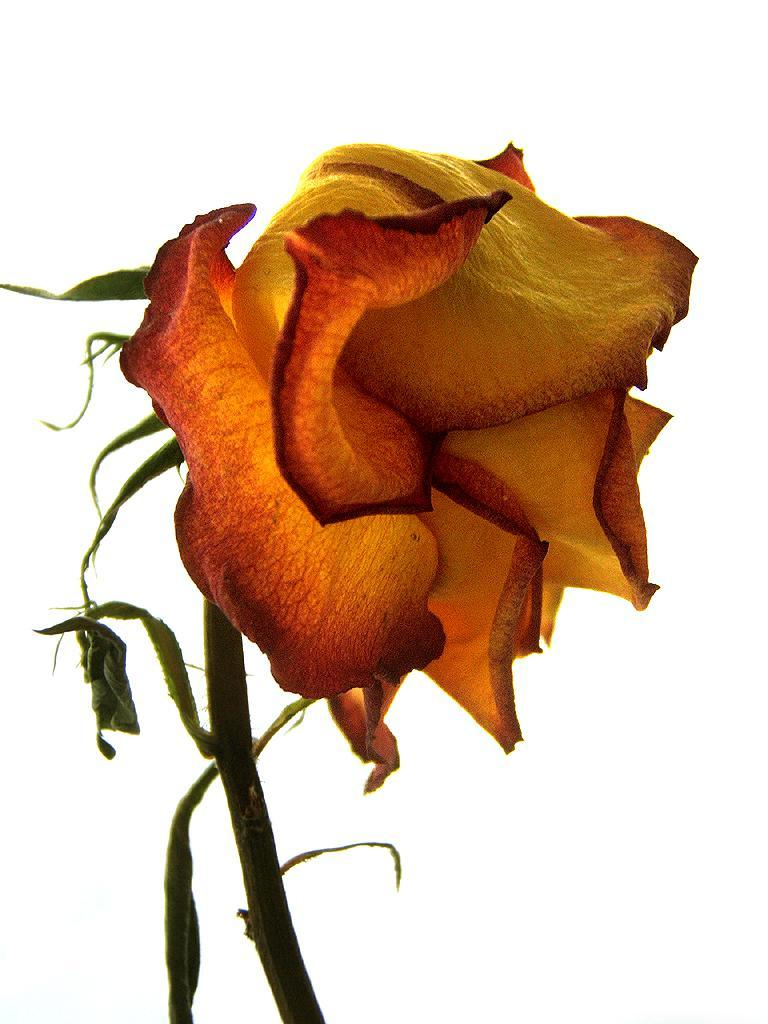What type of flower is in the image? There is a rose flower in the image. Can you describe the rose flower in more detail? The rose flower has a stem. What type of tank is visible in the image? There is no tank present in the image; it features a rose flower with a stem. Can you describe the elbow of the person holding the rose in the image? There is no person holding the rose in the image, so it is not possible to describe an elbow. 